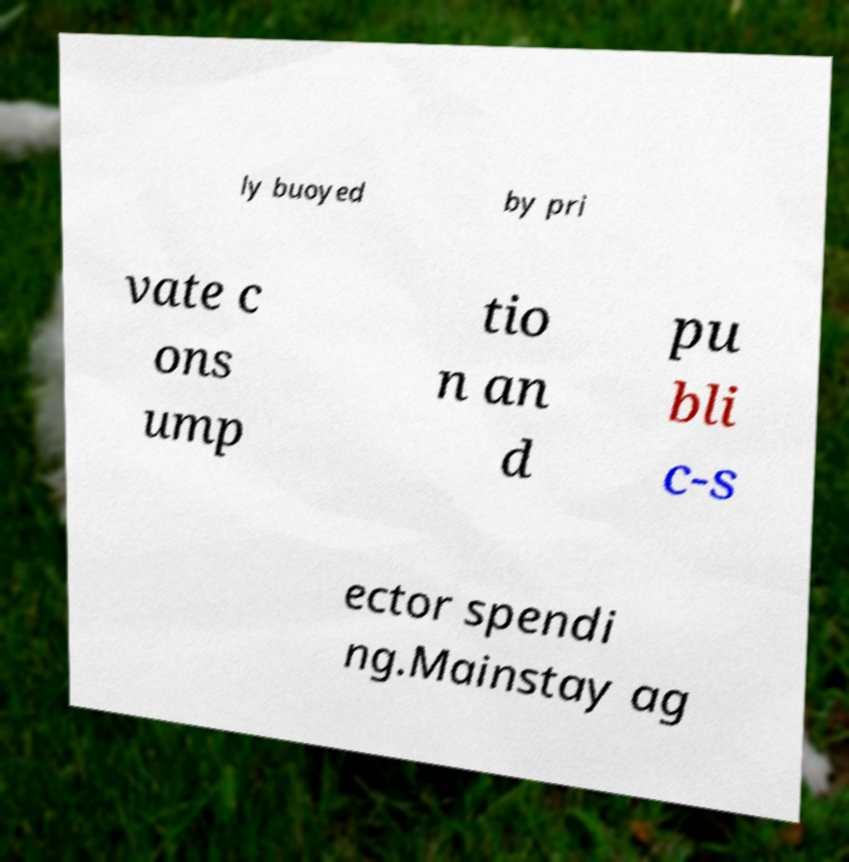Could you extract and type out the text from this image? ly buoyed by pri vate c ons ump tio n an d pu bli c-s ector spendi ng.Mainstay ag 